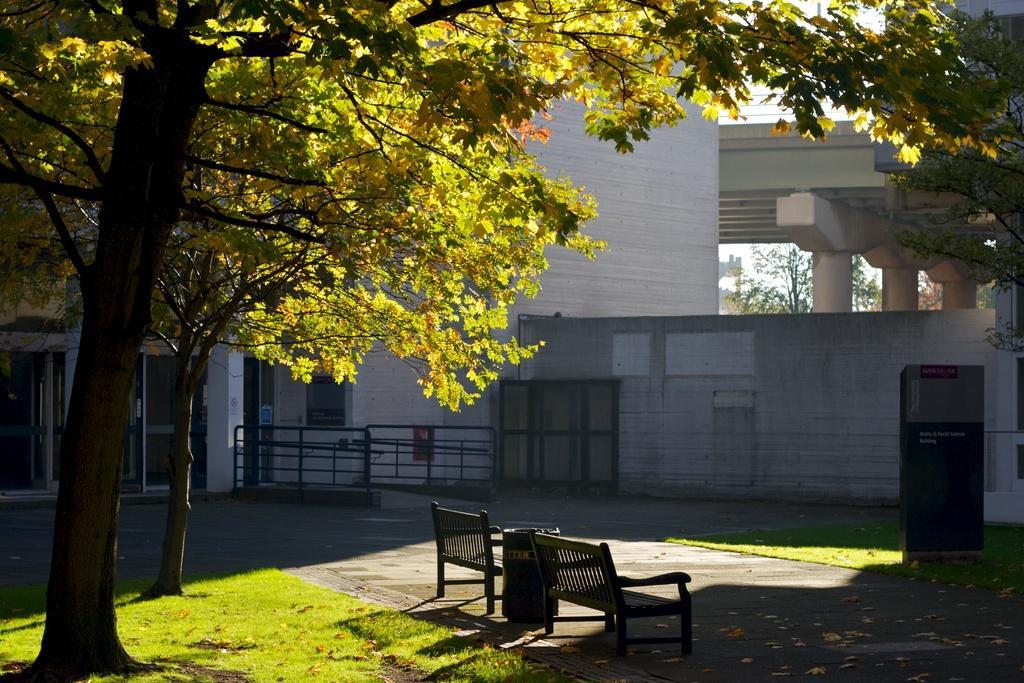Could you give a brief overview of what you see in this image? In this image we can see trees, grass, wooden benches, dustbin, fence, building and the sky in the background. 